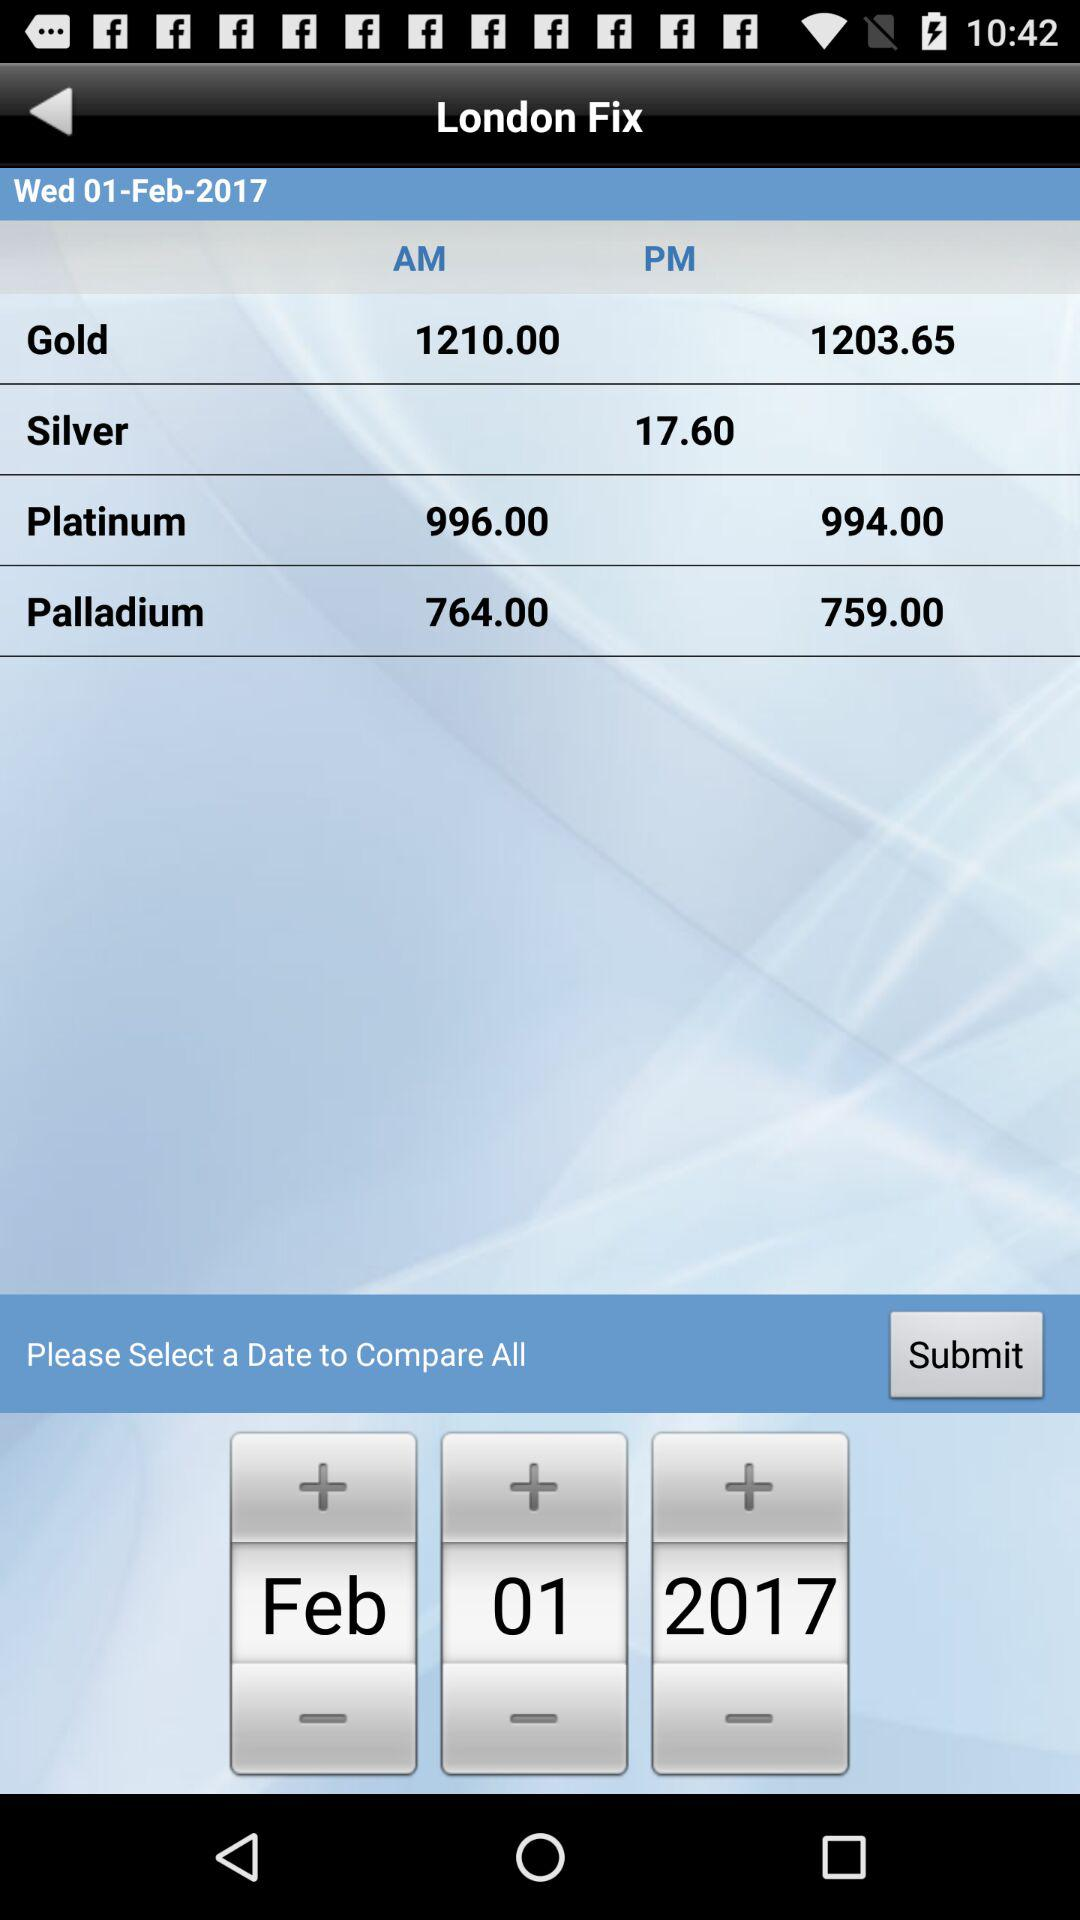What is the price of palladium material? The prices of palladium material are 764 and 759. 